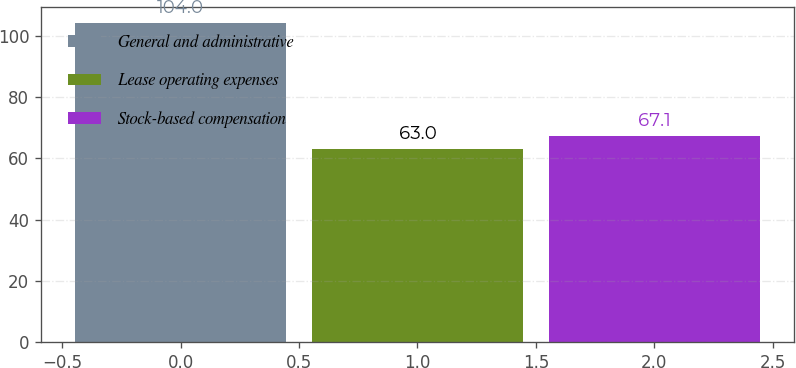<chart> <loc_0><loc_0><loc_500><loc_500><bar_chart><fcel>General and administrative<fcel>Lease operating expenses<fcel>Stock-based compensation<nl><fcel>104<fcel>63<fcel>67.1<nl></chart> 